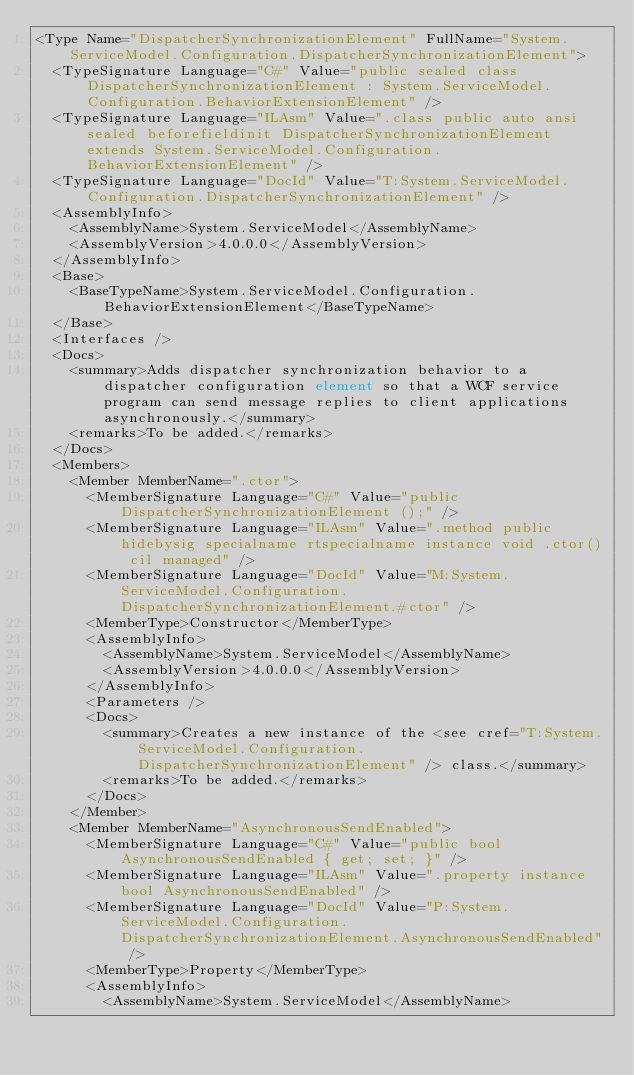<code> <loc_0><loc_0><loc_500><loc_500><_XML_><Type Name="DispatcherSynchronizationElement" FullName="System.ServiceModel.Configuration.DispatcherSynchronizationElement">
  <TypeSignature Language="C#" Value="public sealed class DispatcherSynchronizationElement : System.ServiceModel.Configuration.BehaviorExtensionElement" />
  <TypeSignature Language="ILAsm" Value=".class public auto ansi sealed beforefieldinit DispatcherSynchronizationElement extends System.ServiceModel.Configuration.BehaviorExtensionElement" />
  <TypeSignature Language="DocId" Value="T:System.ServiceModel.Configuration.DispatcherSynchronizationElement" />
  <AssemblyInfo>
    <AssemblyName>System.ServiceModel</AssemblyName>
    <AssemblyVersion>4.0.0.0</AssemblyVersion>
  </AssemblyInfo>
  <Base>
    <BaseTypeName>System.ServiceModel.Configuration.BehaviorExtensionElement</BaseTypeName>
  </Base>
  <Interfaces />
  <Docs>
    <summary>Adds dispatcher synchronization behavior to a dispatcher configuration element so that a WCF service program can send message replies to client applications asynchronously.</summary>
    <remarks>To be added.</remarks>
  </Docs>
  <Members>
    <Member MemberName=".ctor">
      <MemberSignature Language="C#" Value="public DispatcherSynchronizationElement ();" />
      <MemberSignature Language="ILAsm" Value=".method public hidebysig specialname rtspecialname instance void .ctor() cil managed" />
      <MemberSignature Language="DocId" Value="M:System.ServiceModel.Configuration.DispatcherSynchronizationElement.#ctor" />
      <MemberType>Constructor</MemberType>
      <AssemblyInfo>
        <AssemblyName>System.ServiceModel</AssemblyName>
        <AssemblyVersion>4.0.0.0</AssemblyVersion>
      </AssemblyInfo>
      <Parameters />
      <Docs>
        <summary>Creates a new instance of the <see cref="T:System.ServiceModel.Configuration.DispatcherSynchronizationElement" /> class.</summary>
        <remarks>To be added.</remarks>
      </Docs>
    </Member>
    <Member MemberName="AsynchronousSendEnabled">
      <MemberSignature Language="C#" Value="public bool AsynchronousSendEnabled { get; set; }" />
      <MemberSignature Language="ILAsm" Value=".property instance bool AsynchronousSendEnabled" />
      <MemberSignature Language="DocId" Value="P:System.ServiceModel.Configuration.DispatcherSynchronizationElement.AsynchronousSendEnabled" />
      <MemberType>Property</MemberType>
      <AssemblyInfo>
        <AssemblyName>System.ServiceModel</AssemblyName></code> 